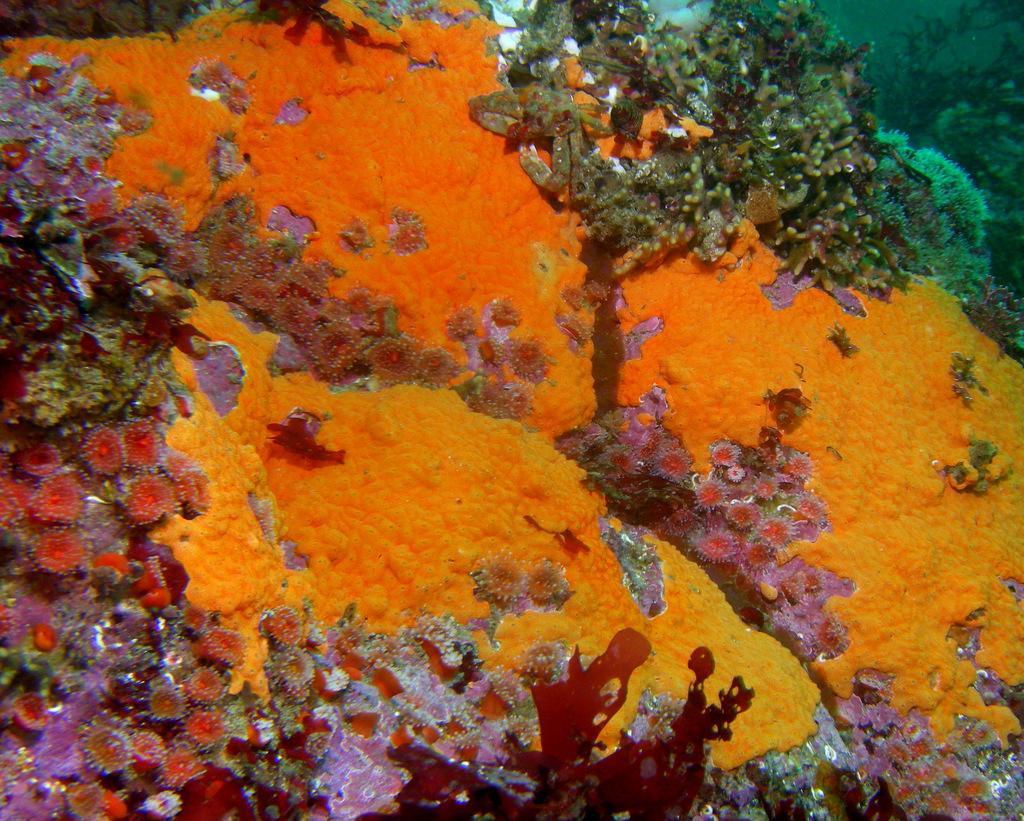What type of natural formation can be seen in the image? There are corals visible in the image. Where are the corals located? The corals are underwater. What type of playground equipment can be seen in the image? There is no playground equipment present in the image; it features corals underwater. 